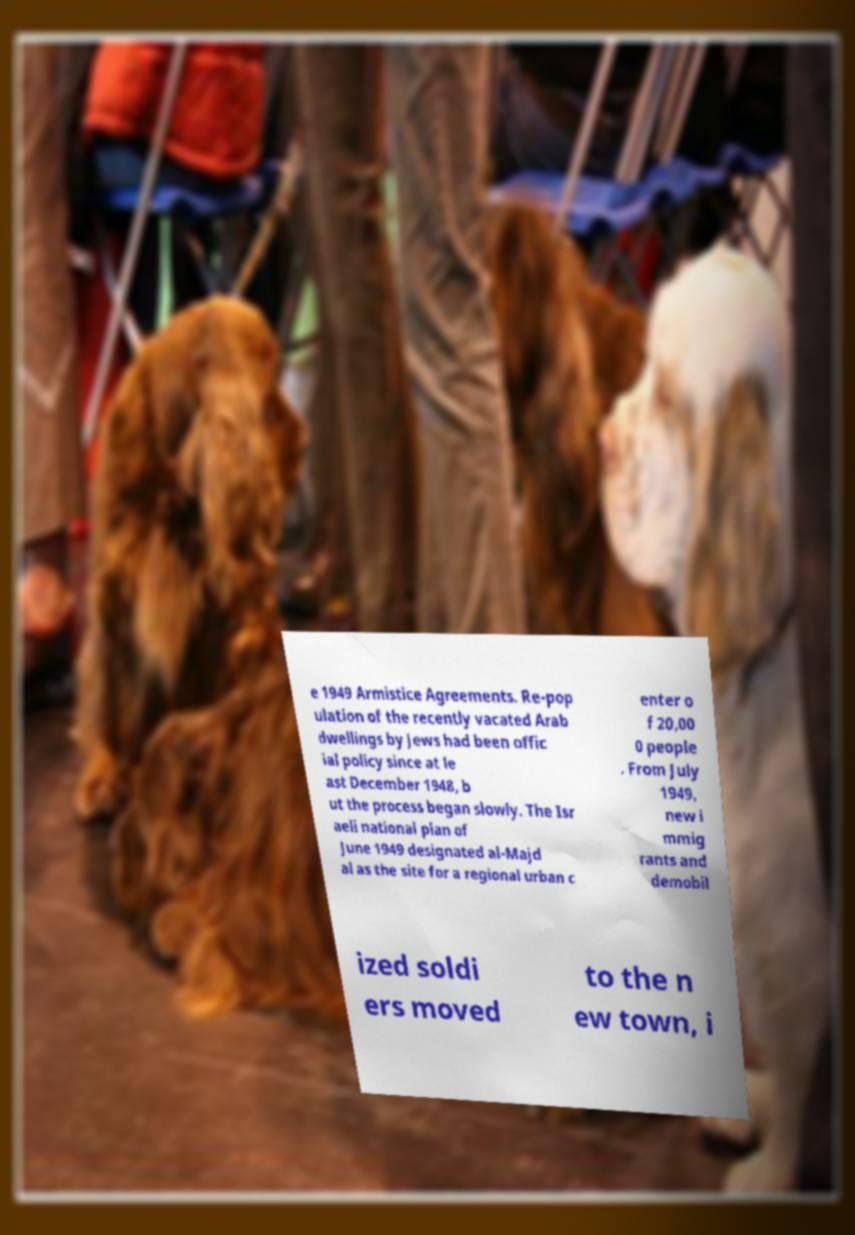I need the written content from this picture converted into text. Can you do that? e 1949 Armistice Agreements. Re-pop ulation of the recently vacated Arab dwellings by Jews had been offic ial policy since at le ast December 1948, b ut the process began slowly. The Isr aeli national plan of June 1949 designated al-Majd al as the site for a regional urban c enter o f 20,00 0 people . From July 1949, new i mmig rants and demobil ized soldi ers moved to the n ew town, i 